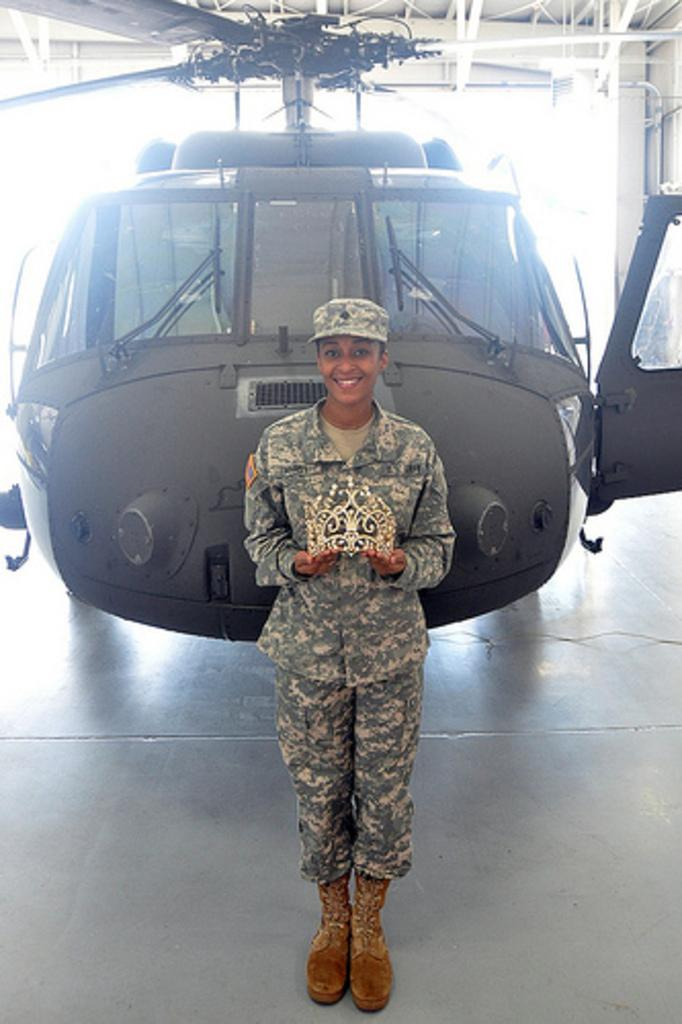What is the main subject of the image? The main subject of the image is a helicopter. Can you describe the position of the helicopter in the image? The helicopter is on the floor in the image. Who else is present in the image? There is a woman in the image. What is the woman's expression in the image? The woman is smiling in the image. What is the woman holding in the image? The woman is holding an object in the image. What type of love can be seen in the image? There is no love present in the image; it features a helicopter on the floor and a woman smiling while holding an object. What country is depicted in the image? There is no country depicted in the image; it only shows a helicopter, a woman, and an object. 